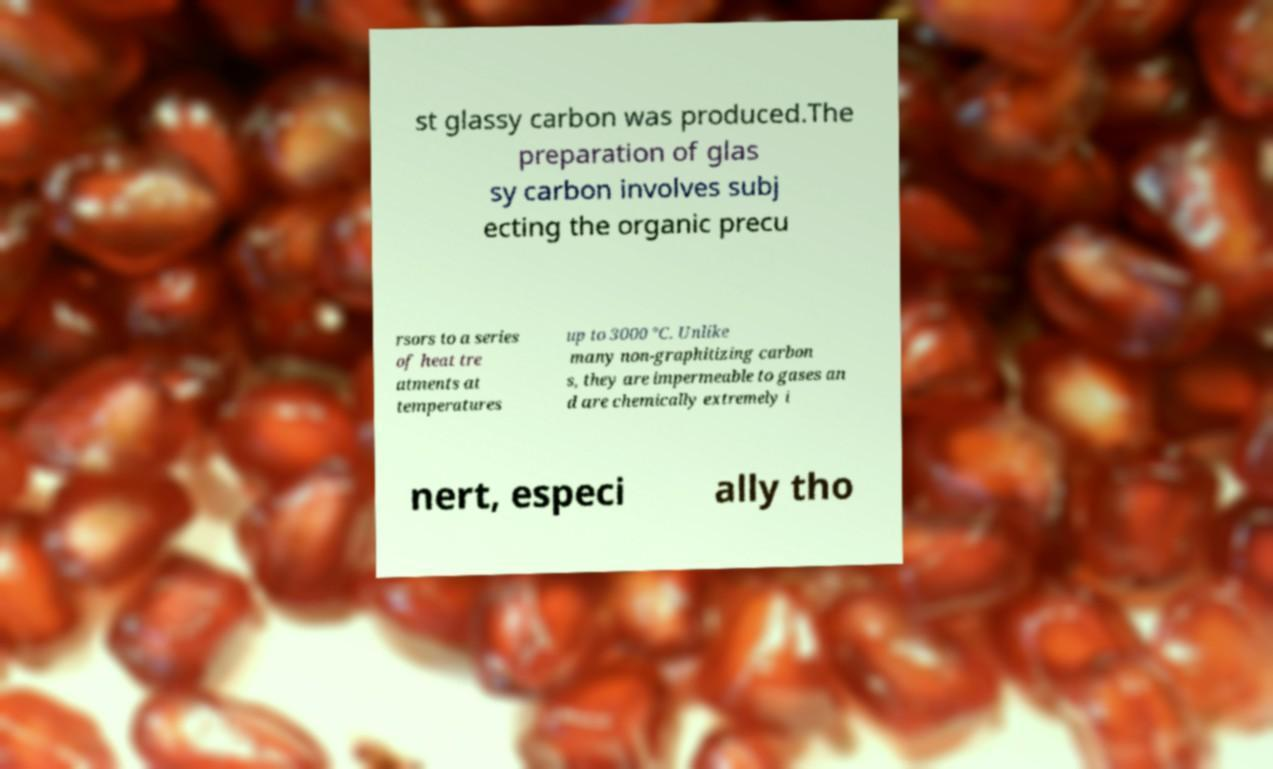Please identify and transcribe the text found in this image. st glassy carbon was produced.The preparation of glas sy carbon involves subj ecting the organic precu rsors to a series of heat tre atments at temperatures up to 3000 °C. Unlike many non-graphitizing carbon s, they are impermeable to gases an d are chemically extremely i nert, especi ally tho 